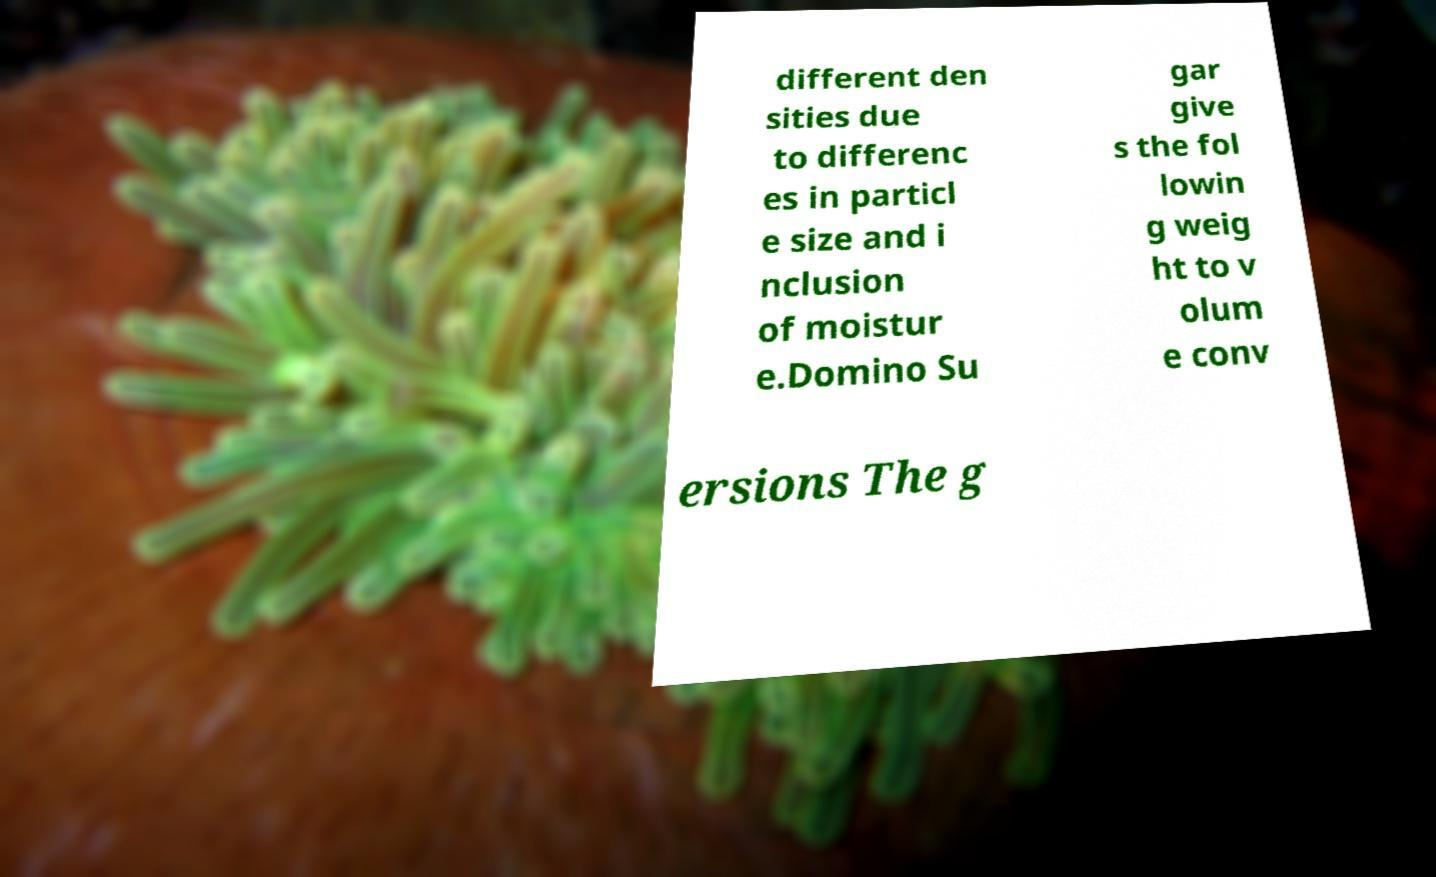Could you extract and type out the text from this image? different den sities due to differenc es in particl e size and i nclusion of moistur e.Domino Su gar give s the fol lowin g weig ht to v olum e conv ersions The g 